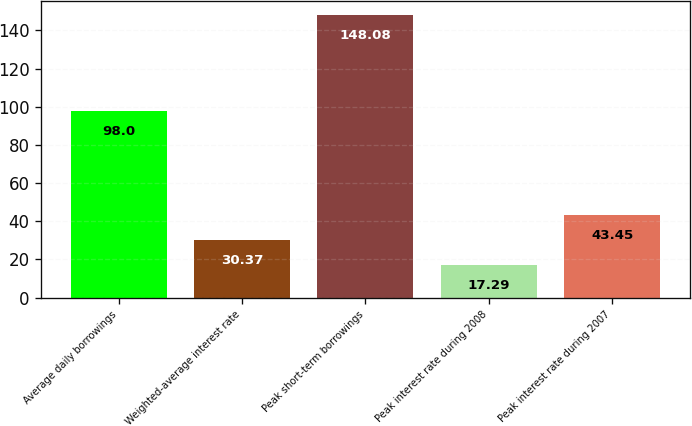<chart> <loc_0><loc_0><loc_500><loc_500><bar_chart><fcel>Average daily borrowings<fcel>Weighted-average interest rate<fcel>Peak short-term borrowings<fcel>Peak interest rate during 2008<fcel>Peak interest rate during 2007<nl><fcel>98<fcel>30.37<fcel>148.08<fcel>17.29<fcel>43.45<nl></chart> 